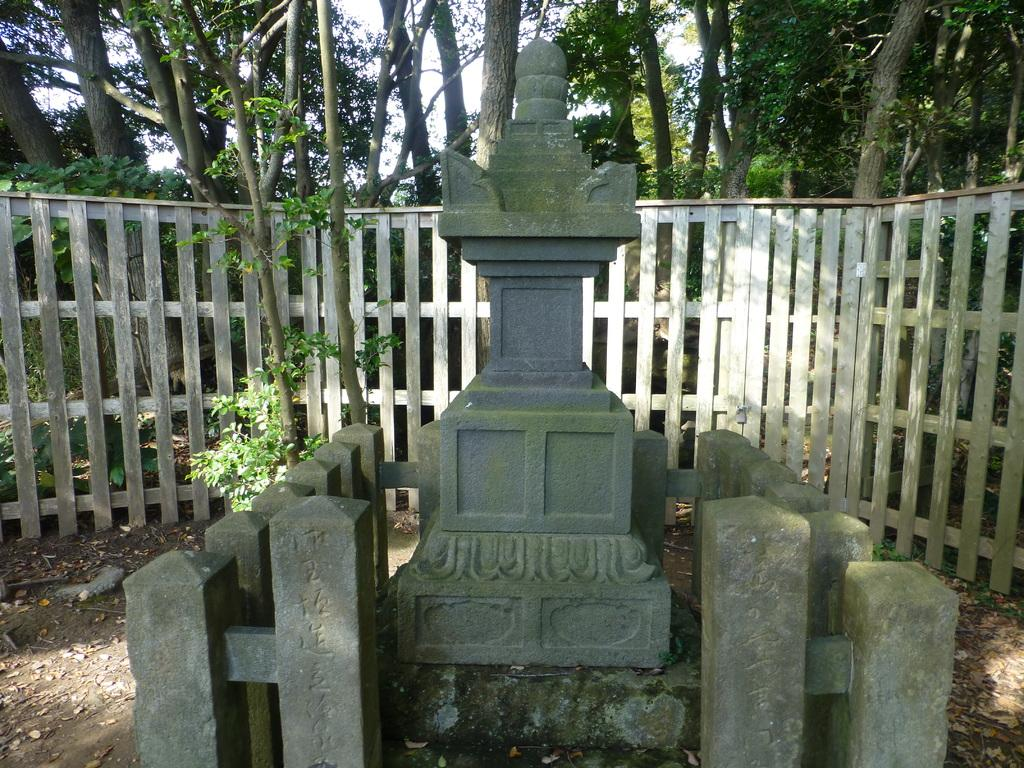What is the main subject in the middle of the image? There is a statue in the middle of the image. What can be seen at the top of the image? There are trees at the top of the image. What type of vegetation is present in the middle of the image? There are plants in the middle of the image. What type of paste is being used to hold the statue together in the image? There is no mention of paste or any substance being used to hold the statue together in the image. 